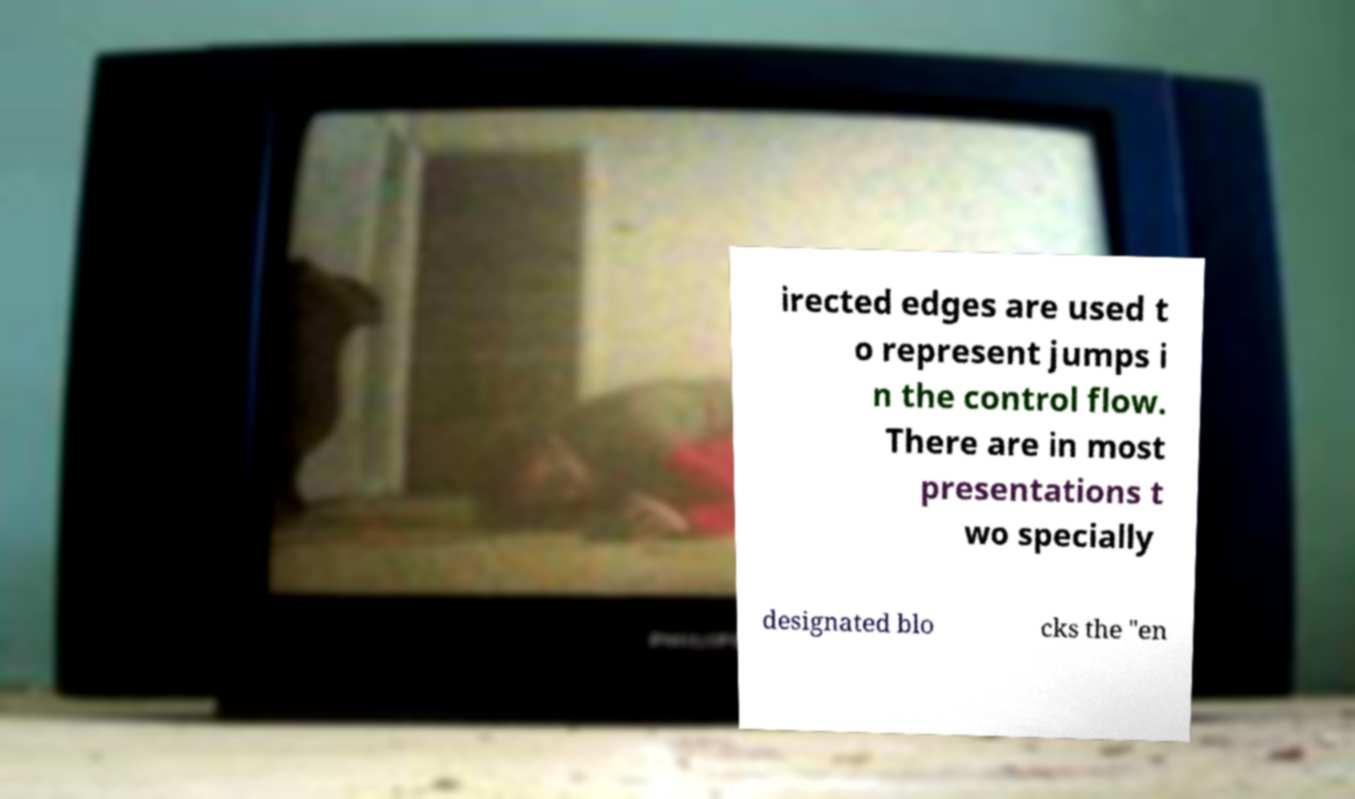For documentation purposes, I need the text within this image transcribed. Could you provide that? irected edges are used t o represent jumps i n the control flow. There are in most presentations t wo specially designated blo cks the "en 